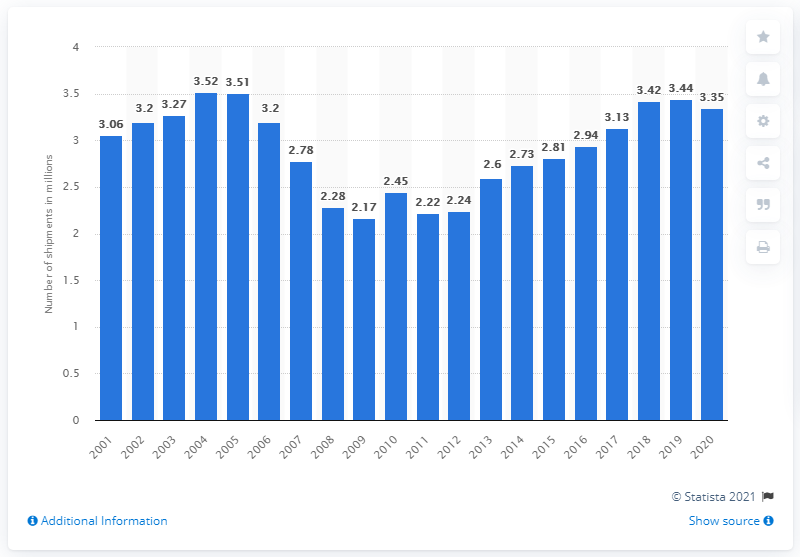Outline some significant characteristics in this image. In 2020, the United States shipped a total of 3.35 gas warm air furnaces. 